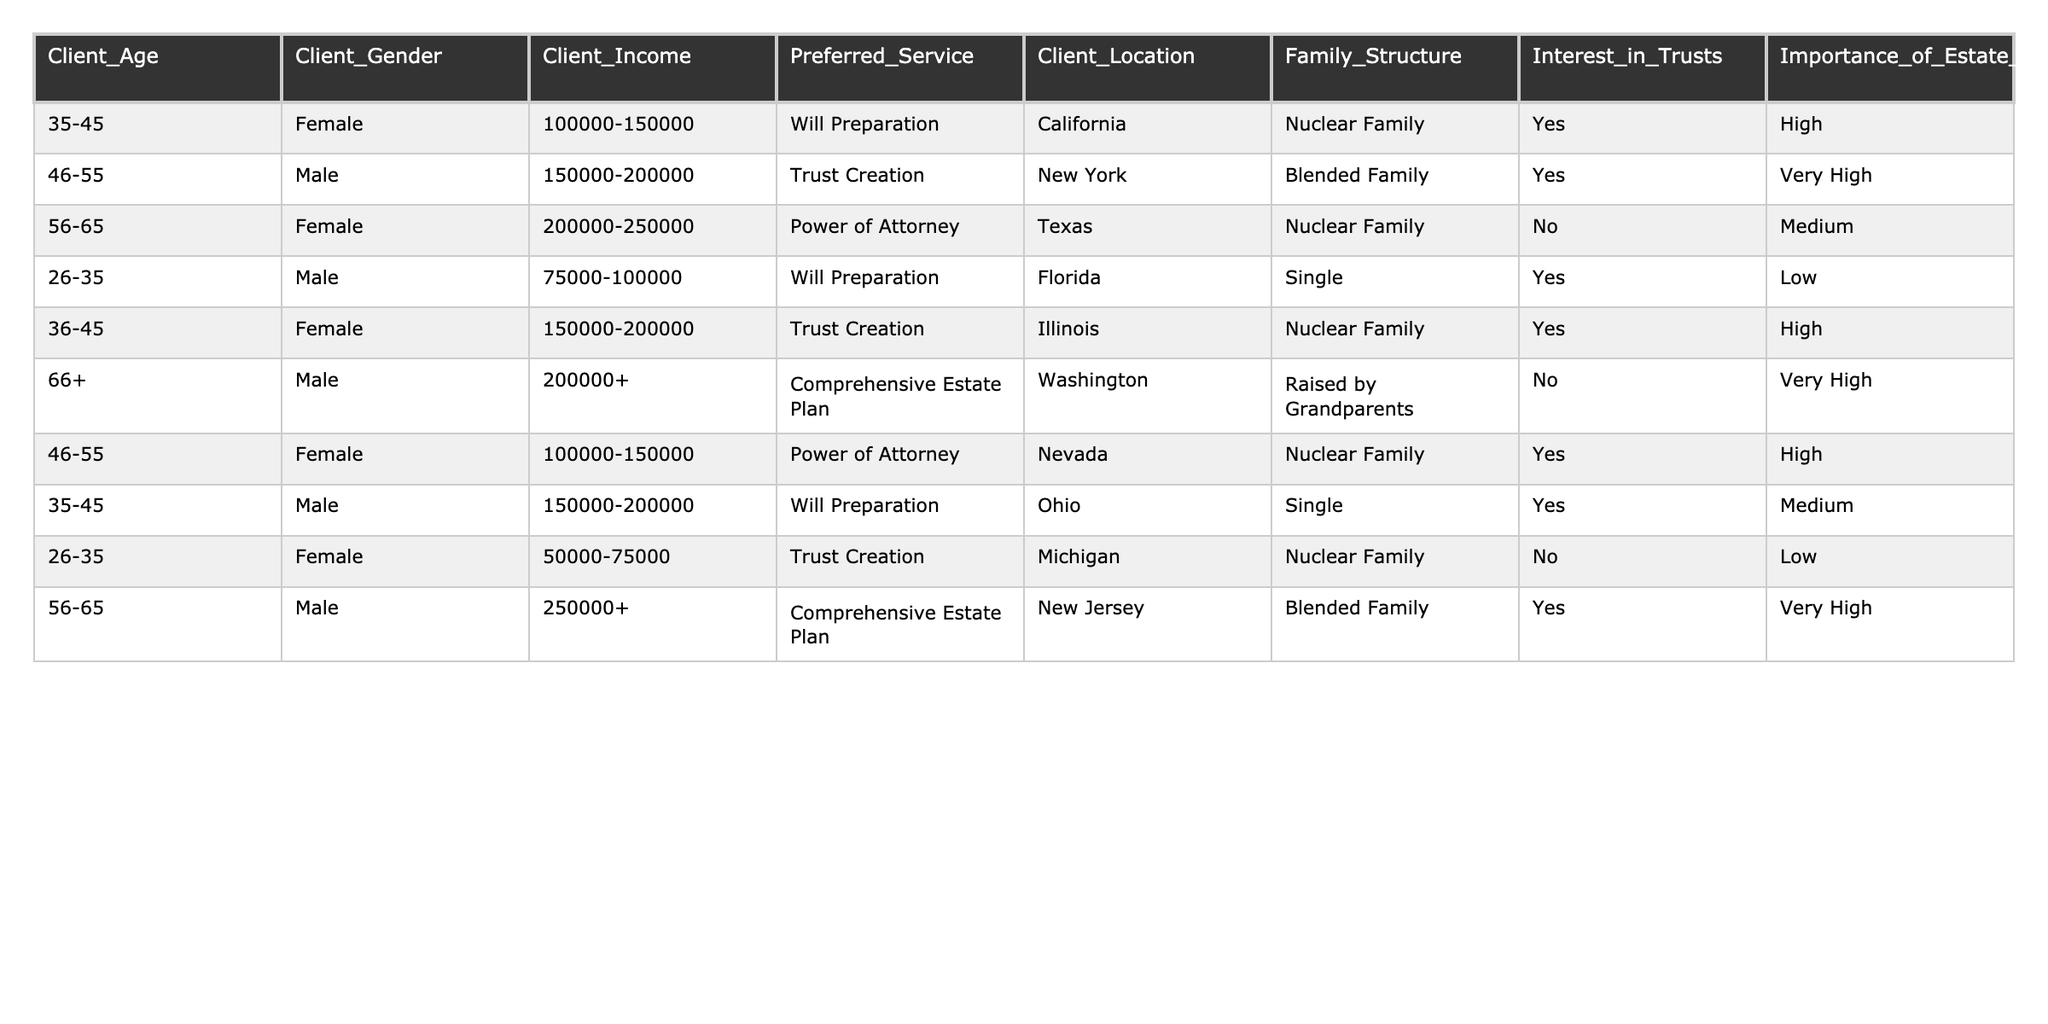What is the preferred service for clients aged 56-65? The table shows that clients aged 56-65 have two entries: one prefers Power of Attorney, and the other prefers Comprehensive Estate Plan. Therefore, there is no single preferred service for clients in this age group; it varies based on individual preferences.
Answer: No single preferred service How many clients are interested in trusts? The table lists six clients. Out of these, clients who answered "Yes" to the interest in trusts are Client A, Client B, Client D, and Client H, totaling four clients.
Answer: Four clients What is the most common family structure among clients preferring Will Preparation? By examining the table, Client A and Client D prefer Will Preparation, and they both belong to a Nuclear Family structure. Thus, the most common family structure for clients preferring Will Preparation is Nuclear Family.
Answer: Nuclear Family Are there any clients aged 66 and above who are interested in trusts? The only client in the 66+ age bracket, Client F, responded "No" to the interest in trusts. Thus, there are no clients aged 66 and above interested in trusts.
Answer: No What is the average income level of clients preferring Trust Creation? The income levels for clients preferring Trust Creation are: Client B with 150000-200000, Client D with 75000-100000, and Client H with 250000+. To find the average, we need to consider the ranges only, leading to an estimation between approximately 150000 and 200000.
Answer: Approximately 150000-200000 How many clients prefer Power of Attorney and have a Family Structure categorized as Blended Family? There are two clients who prefer Power of Attorney: Client C and Client F. Checking their family structures, Client C belongs to a Nuclear Family, and Client F belongs to a Blended Family. Hence, only one client prefers Power of Attorney with a Blended Family structure.
Answer: One client What percentage of clients from Texas are interested in estate tax strategy? There are three clients from Texas in the table, of which only one (Client C) indicated that estate tax strategy is important (medium). Therefore, the percentage of Texas clients interested in estate tax strategy is (1/3) * 100% = 33.33%.
Answer: Approximately 33% Which gender is more likely to be interested in trusts based on the table? Analyzing the interest in trusts, we find three females (Clients A, C, and H) and four males (Clients B, D, F, and G) interested in trusts, leading to a comparison of interests based on gender. Here, males show a higher interest in trusts.
Answer: Males 